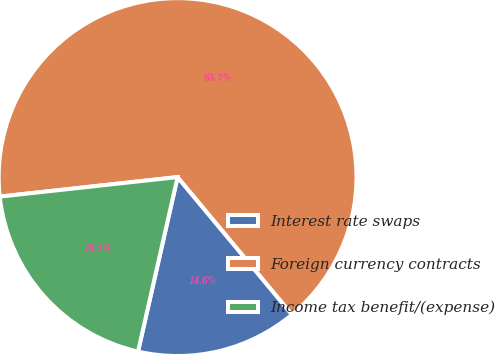Convert chart to OTSL. <chart><loc_0><loc_0><loc_500><loc_500><pie_chart><fcel>Interest rate swaps<fcel>Foreign currency contracts<fcel>Income tax benefit/(expense)<nl><fcel>14.6%<fcel>65.69%<fcel>19.71%<nl></chart> 